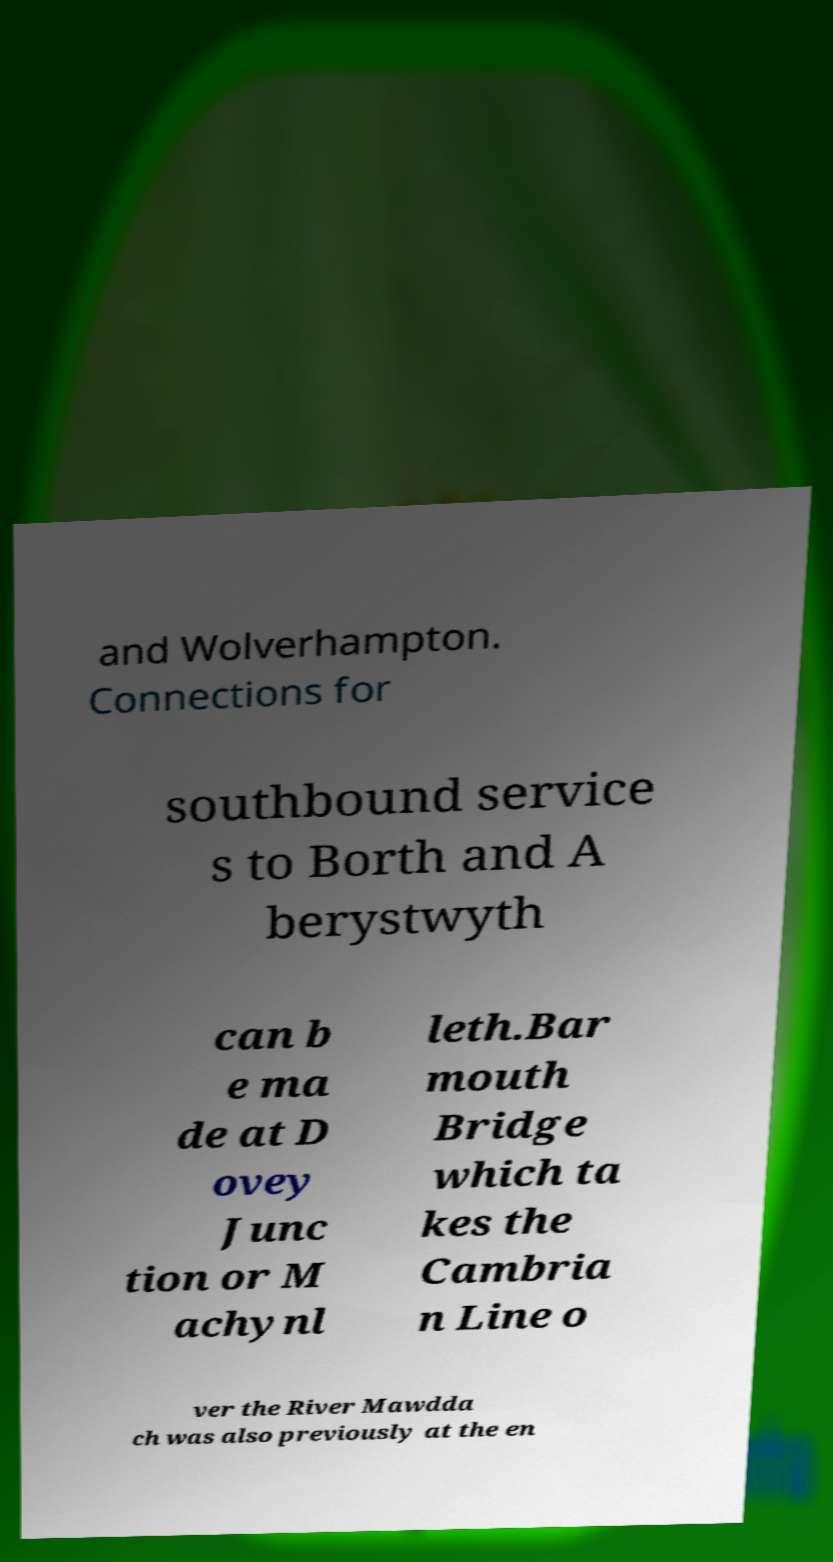Can you accurately transcribe the text from the provided image for me? and Wolverhampton. Connections for southbound service s to Borth and A berystwyth can b e ma de at D ovey Junc tion or M achynl leth.Bar mouth Bridge which ta kes the Cambria n Line o ver the River Mawdda ch was also previously at the en 